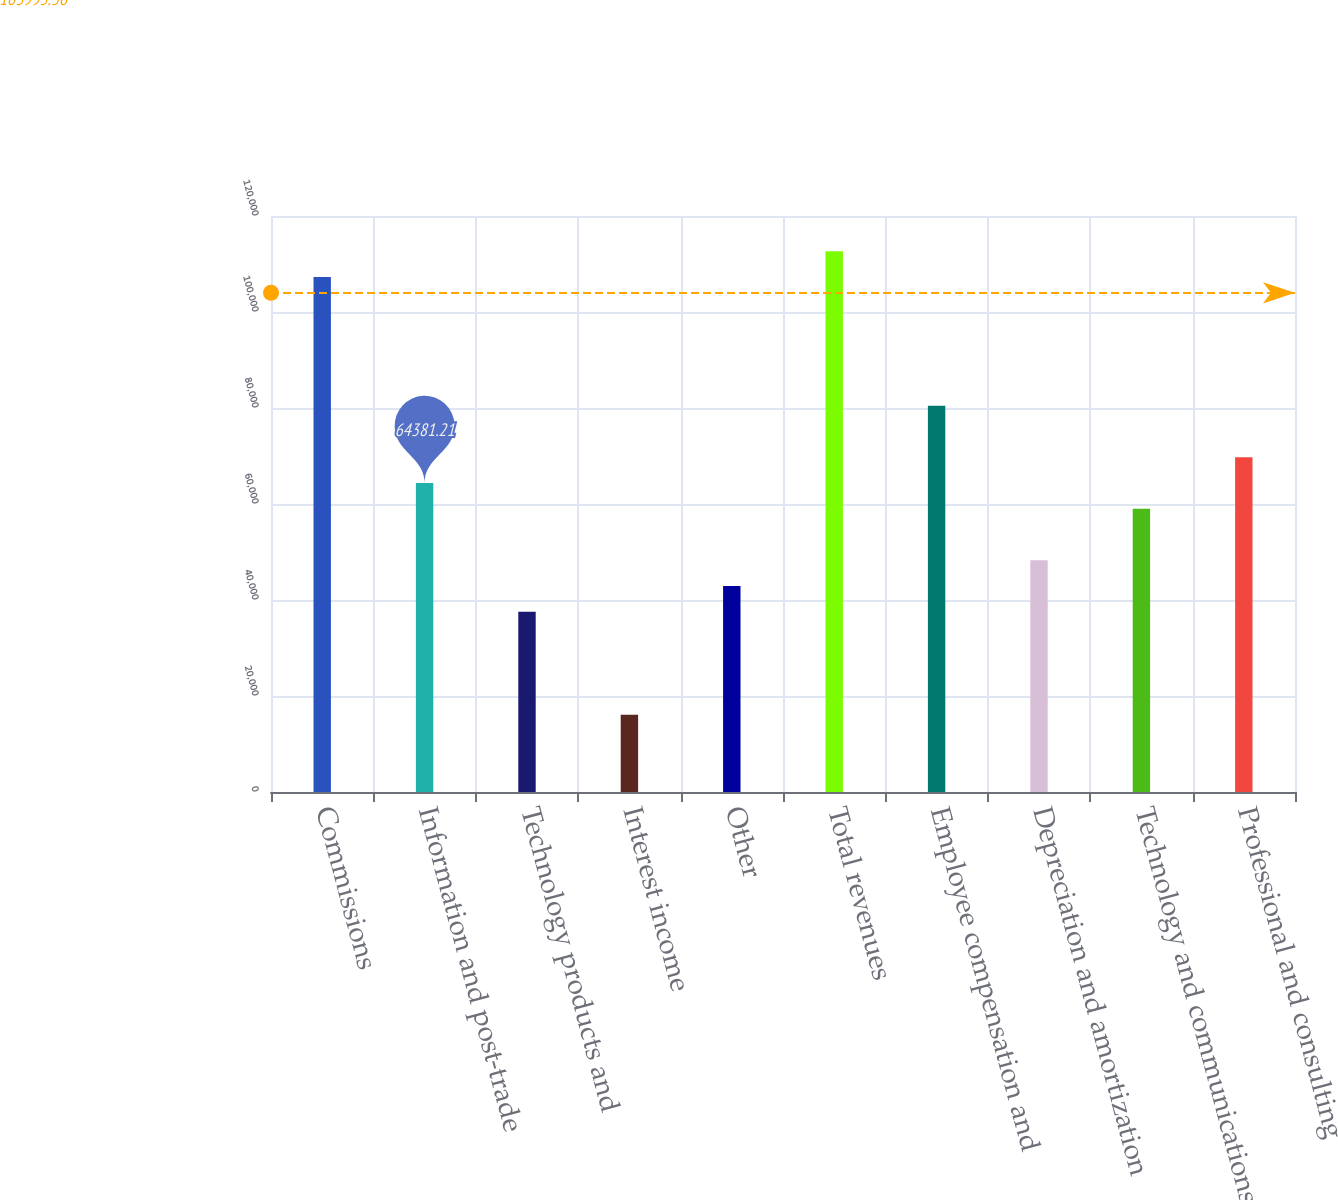Convert chart. <chart><loc_0><loc_0><loc_500><loc_500><bar_chart><fcel>Commissions<fcel>Information and post-trade<fcel>Technology products and<fcel>Interest income<fcel>Other<fcel>Total revenues<fcel>Employee compensation and<fcel>Depreciation and amortization<fcel>Technology and communications<fcel>Professional and consulting<nl><fcel>107302<fcel>64381.2<fcel>37555.7<fcel>16095.3<fcel>42920.8<fcel>112667<fcel>80476.5<fcel>48285.9<fcel>59016.1<fcel>69746.3<nl></chart> 